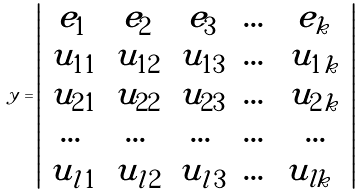Convert formula to latex. <formula><loc_0><loc_0><loc_500><loc_500>y = \left | \begin{array} { c c c c c } e _ { 1 } & e _ { 2 } & e _ { 3 } & \dots & e _ { k } \\ u _ { 1 1 } & u _ { 1 2 } & u _ { 1 3 } & \dots & u _ { 1 k } \\ u _ { 2 1 } & u _ { 2 2 } & u _ { 2 3 } & \dots & u _ { 2 k } \\ \dots & \dots & \dots & \dots & \dots \\ u _ { l 1 } & u _ { l 2 } & u _ { l 3 } & \dots & u _ { l k } \ \end{array} \right |</formula> 